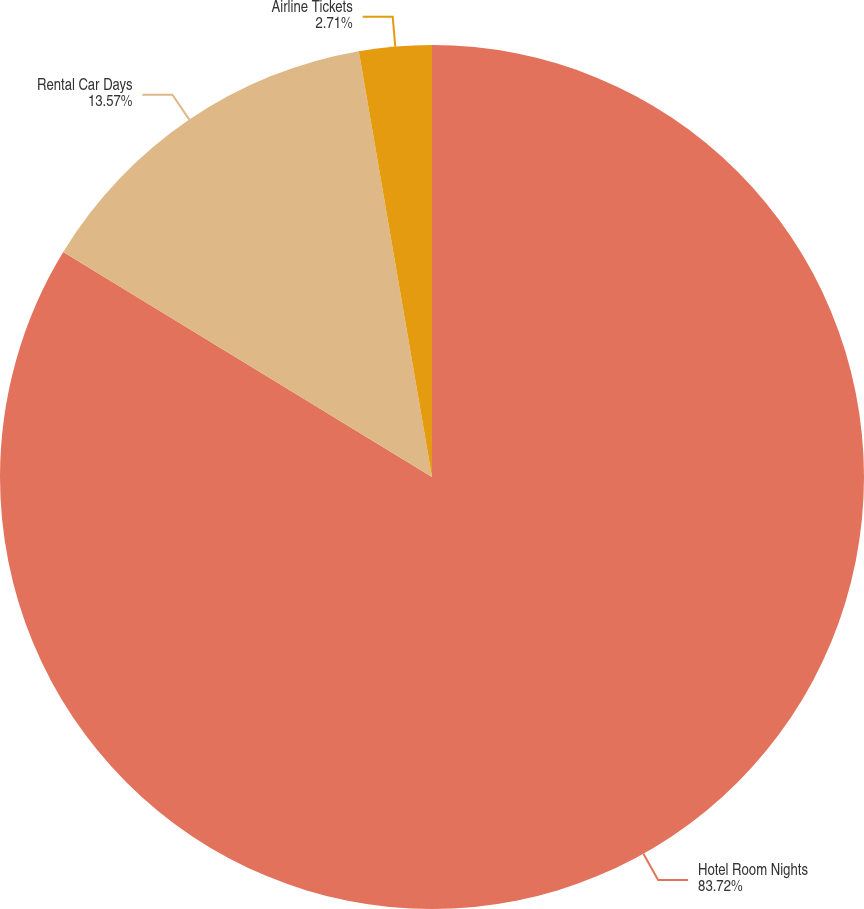Convert chart. <chart><loc_0><loc_0><loc_500><loc_500><pie_chart><fcel>Hotel Room Nights<fcel>Rental Car Days<fcel>Airline Tickets<nl><fcel>83.72%<fcel>13.57%<fcel>2.71%<nl></chart> 